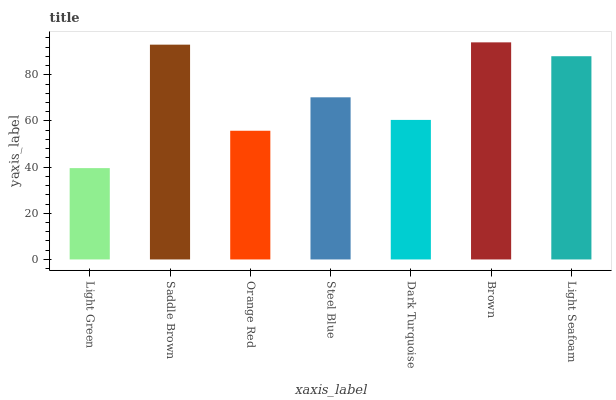Is Light Green the minimum?
Answer yes or no. Yes. Is Brown the maximum?
Answer yes or no. Yes. Is Saddle Brown the minimum?
Answer yes or no. No. Is Saddle Brown the maximum?
Answer yes or no. No. Is Saddle Brown greater than Light Green?
Answer yes or no. Yes. Is Light Green less than Saddle Brown?
Answer yes or no. Yes. Is Light Green greater than Saddle Brown?
Answer yes or no. No. Is Saddle Brown less than Light Green?
Answer yes or no. No. Is Steel Blue the high median?
Answer yes or no. Yes. Is Steel Blue the low median?
Answer yes or no. Yes. Is Orange Red the high median?
Answer yes or no. No. Is Brown the low median?
Answer yes or no. No. 